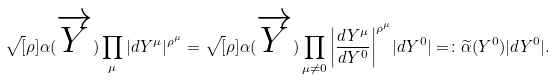Convert formula to latex. <formula><loc_0><loc_0><loc_500><loc_500>\sqrt { [ } \rho ] { \alpha ( \overrightarrow { Y } ) \prod _ { \mu } | d Y ^ { \mu } | ^ { \rho ^ { \mu } } } = \sqrt { [ } \rho ] { \alpha ( \overrightarrow { Y } ) \prod _ { \mu \neq 0 } \left | \frac { d Y ^ { \mu } } { d Y ^ { 0 } } \right | ^ { \rho ^ { \mu } } } | d Y ^ { 0 } | = \colon \widetilde { \alpha } ( Y ^ { 0 } ) | d Y ^ { 0 } | .</formula> 